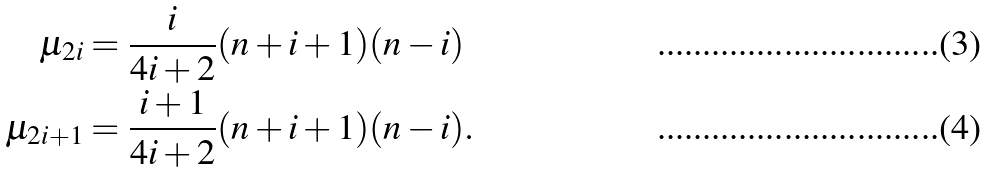<formula> <loc_0><loc_0><loc_500><loc_500>\mu _ { 2 i } & = \frac { i } { 4 i + 2 } ( n + i + 1 ) ( n - i ) \\ \mu _ { 2 i + 1 } & = \frac { i + 1 } { 4 i + 2 } ( n + i + 1 ) ( n - i ) .</formula> 